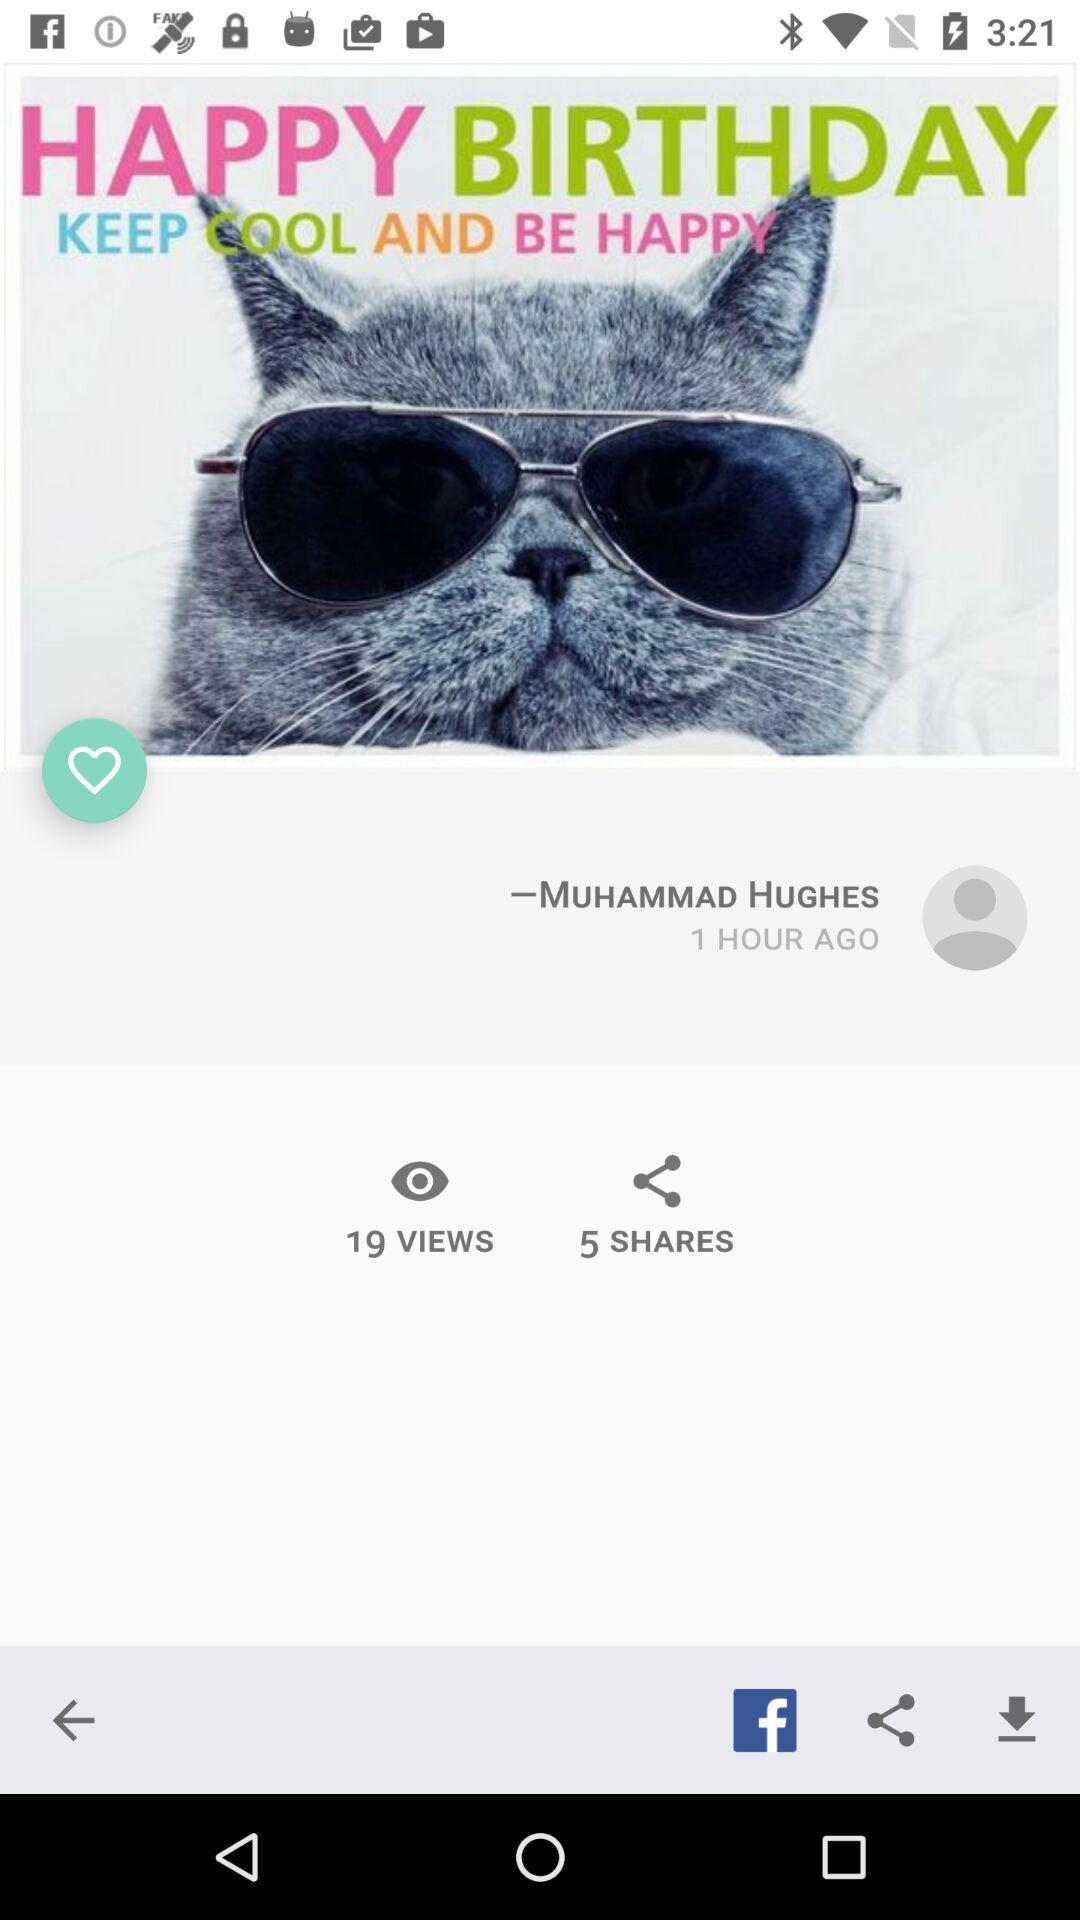How many more views than shares does the post have?
Answer the question using a single word or phrase. 14 